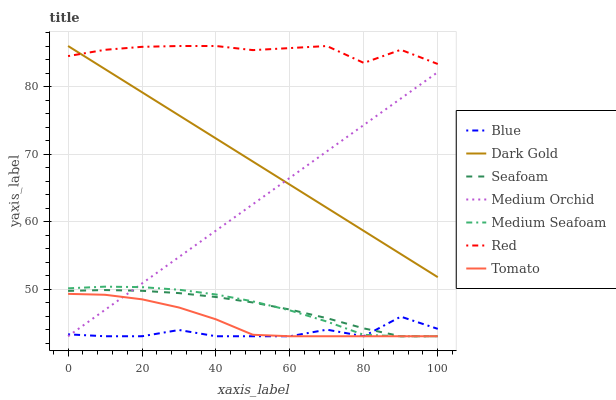Does Blue have the minimum area under the curve?
Answer yes or no. Yes. Does Red have the maximum area under the curve?
Answer yes or no. Yes. Does Tomato have the minimum area under the curve?
Answer yes or no. No. Does Tomato have the maximum area under the curve?
Answer yes or no. No. Is Dark Gold the smoothest?
Answer yes or no. Yes. Is Blue the roughest?
Answer yes or no. Yes. Is Tomato the smoothest?
Answer yes or no. No. Is Tomato the roughest?
Answer yes or no. No. Does Blue have the lowest value?
Answer yes or no. Yes. Does Dark Gold have the lowest value?
Answer yes or no. No. Does Red have the highest value?
Answer yes or no. Yes. Does Tomato have the highest value?
Answer yes or no. No. Is Tomato less than Dark Gold?
Answer yes or no. Yes. Is Dark Gold greater than Tomato?
Answer yes or no. Yes. Does Medium Orchid intersect Blue?
Answer yes or no. Yes. Is Medium Orchid less than Blue?
Answer yes or no. No. Is Medium Orchid greater than Blue?
Answer yes or no. No. Does Tomato intersect Dark Gold?
Answer yes or no. No. 